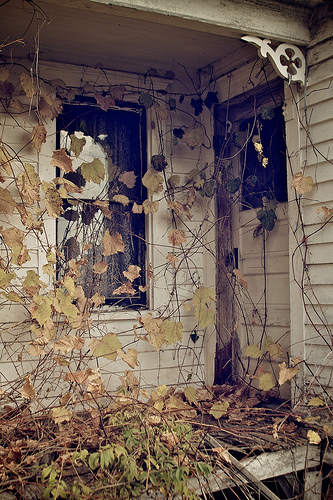<image>
Can you confirm if the leaf is in front of the wall? Yes. The leaf is positioned in front of the wall, appearing closer to the camera viewpoint. 